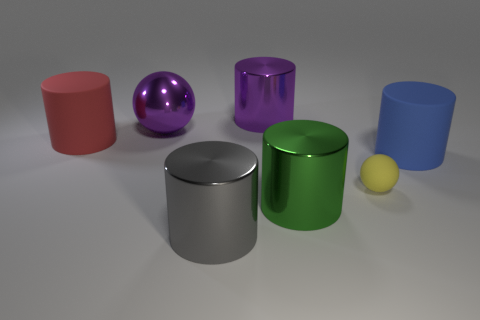What is the color of the big ball?
Offer a terse response. Purple. There is a large matte thing that is behind the blue rubber thing; does it have the same shape as the big green thing?
Make the answer very short. Yes. What number of objects are either tiny yellow rubber spheres or large blue rubber cylinders that are on the right side of the yellow rubber sphere?
Your answer should be very brief. 2. Are the large thing that is behind the big purple sphere and the green thing made of the same material?
Make the answer very short. Yes. Is there anything else that has the same size as the purple metallic sphere?
Make the answer very short. Yes. There is a sphere behind the rubber object on the right side of the tiny yellow rubber thing; what is its material?
Your answer should be very brief. Metal. Is the number of red cylinders in front of the large blue object greater than the number of large gray objects that are right of the big gray cylinder?
Your response must be concise. No. The yellow matte ball has what size?
Your answer should be very brief. Small. There is a cylinder behind the metal ball; does it have the same color as the small object?
Offer a terse response. No. Are there any other things that have the same shape as the large gray object?
Offer a terse response. Yes. 